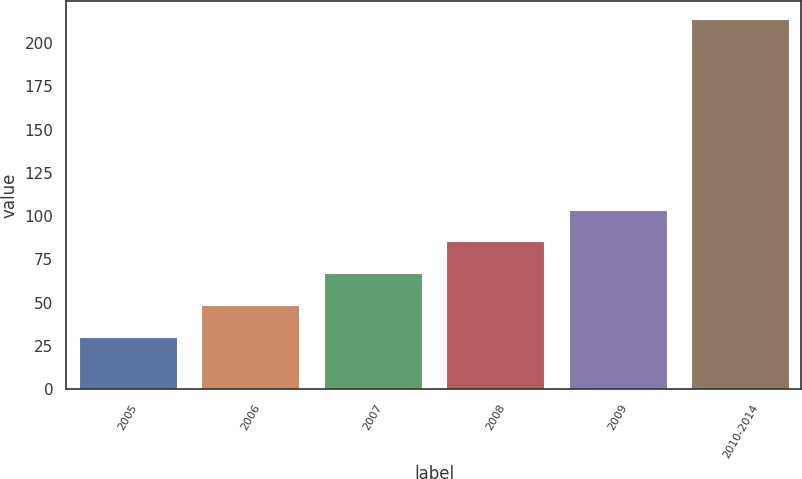Convert chart. <chart><loc_0><loc_0><loc_500><loc_500><bar_chart><fcel>2005<fcel>2006<fcel>2007<fcel>2008<fcel>2009<fcel>2010-2014<nl><fcel>30.4<fcel>48.74<fcel>67.08<fcel>85.42<fcel>103.76<fcel>213.8<nl></chart> 